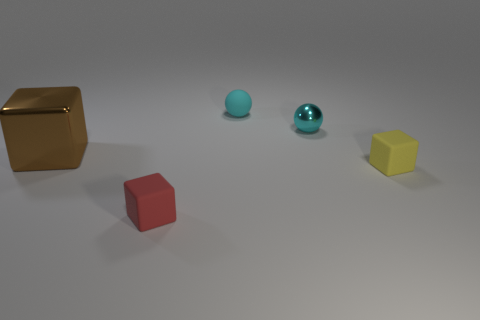Does the rubber sphere have the same color as the shiny sphere?
Offer a terse response. Yes. Is there any other thing that has the same size as the brown block?
Provide a short and direct response. No. How many objects are either rubber things that are in front of the small yellow matte block or small matte things that are on the left side of the small metal sphere?
Provide a succinct answer. 2. Do the object in front of the tiny yellow matte block and the large brown thing have the same material?
Your answer should be very brief. No. There is a thing that is both in front of the big block and on the right side of the cyan rubber thing; what is its material?
Your answer should be very brief. Rubber. What is the color of the metal thing that is left of the tiny matte object behind the tiny yellow matte block?
Keep it short and to the point. Brown. There is a tiny red thing that is the same shape as the big thing; what material is it?
Offer a terse response. Rubber. There is a rubber cube left of the metal object to the right of the tiny rubber object behind the brown cube; what is its color?
Offer a terse response. Red. What number of objects are either large red rubber spheres or red cubes?
Keep it short and to the point. 1. How many small matte objects are the same shape as the small cyan metal object?
Provide a short and direct response. 1. 